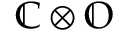<formula> <loc_0><loc_0><loc_500><loc_500>\mathbb { C } \otimes \mathbb { O }</formula> 